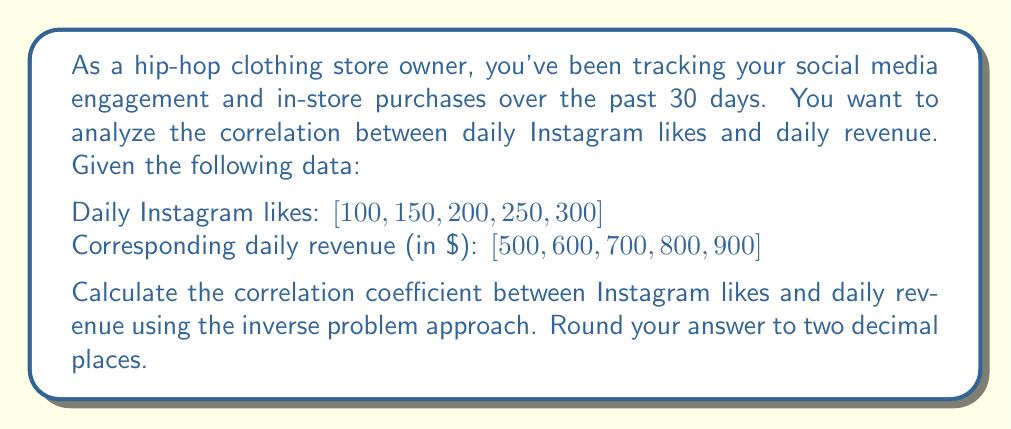Teach me how to tackle this problem. To solve this inverse problem and find the correlation coefficient, we'll follow these steps:

1. Calculate the means of Instagram likes ($\bar{x}$) and daily revenue ($\bar{y}$):
   $$\bar{x} = \frac{100 + 150 + 200 + 250 + 300}{5} = 200$$
   $$\bar{y} = \frac{500 + 600 + 700 + 800 + 900}{5} = 700$$

2. Calculate the deviations from the mean for both variables:
   $x_i - \bar{x}$: $[-100, -50, 0, 50, 100]$
   $y_i - \bar{y}$: $[-200, -100, 0, 100, 200]$

3. Calculate the products of the deviations:
   $(x_i - \bar{x})(y_i - \bar{y})$: $[20000, 5000, 0, 5000, 20000]$

4. Sum the products of deviations:
   $$\sum_{i=1}^{n} (x_i - \bar{x})(y_i - \bar{y}) = 50000$$

5. Calculate the sum of squared deviations for each variable:
   $$\sum_{i=1}^{n} (x_i - \bar{x})^2 = 10000 + 2500 + 0 + 2500 + 10000 = 25000$$
   $$\sum_{i=1}^{n} (y_i - \bar{y})^2 = 40000 + 10000 + 0 + 10000 + 40000 = 100000$$

6. Apply the correlation coefficient formula:
   $$r = \frac{\sum_{i=1}^{n} (x_i - \bar{x})(y_i - \bar{y})}{\sqrt{\sum_{i=1}^{n} (x_i - \bar{x})^2 \sum_{i=1}^{n} (y_i - \bar{y})^2}}$$

   $$r = \frac{50000}{\sqrt{25000 \times 100000}} = \frac{50000}{50000} = 1$$

7. Round the result to two decimal places: 1.00
Answer: 1.00 